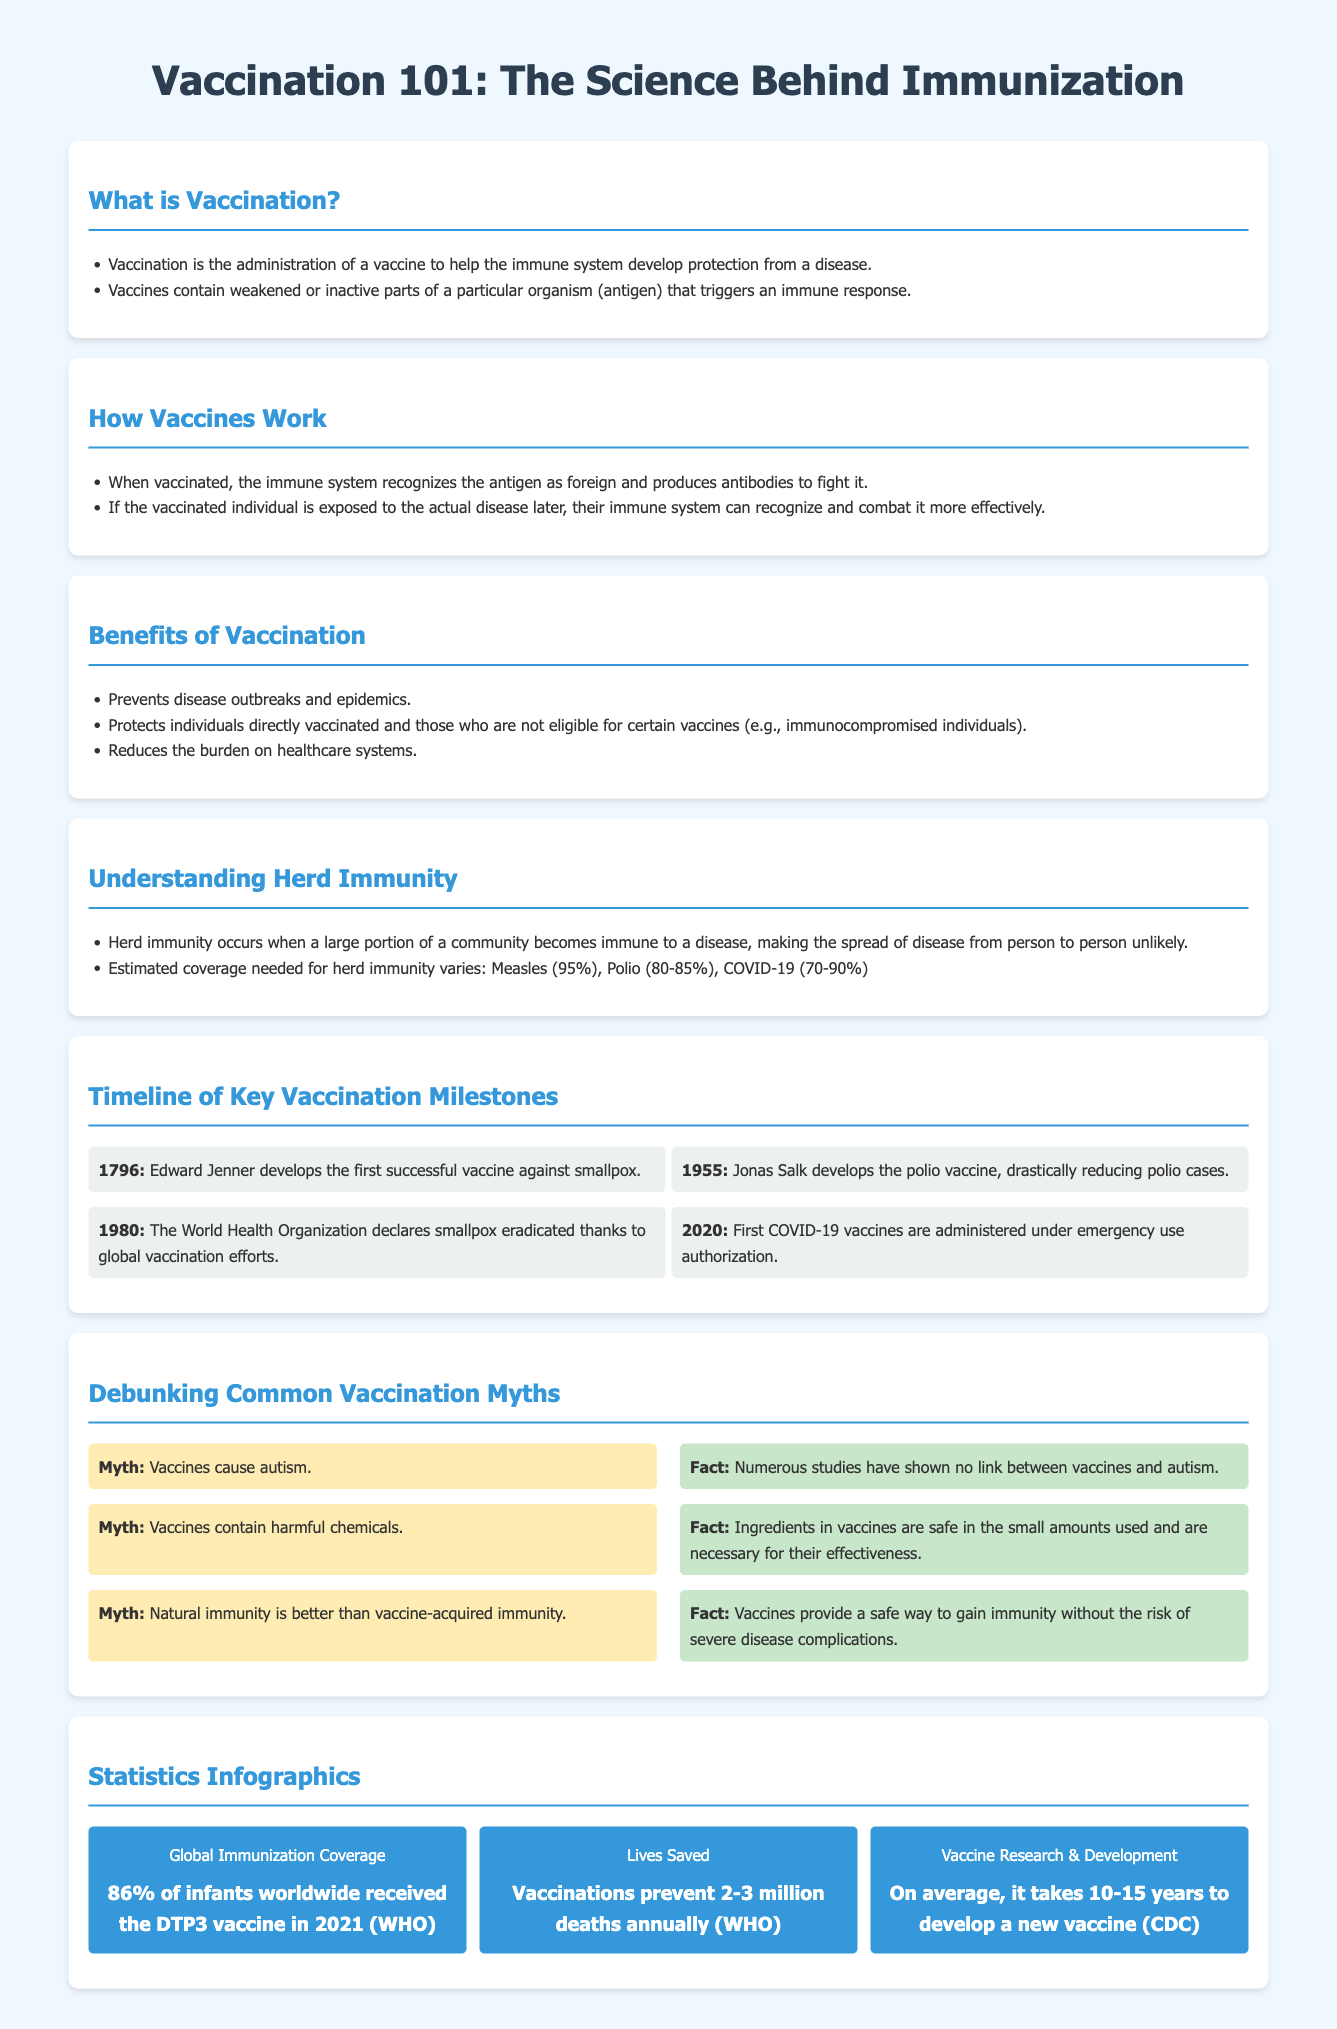What is vaccination? Vaccination is defined in the document as the administration of a vaccine to help the immune system develop protection from a disease.
Answer: Administration of a vaccine What year was the first successful vaccine developed? The timeline mentions that the first successful vaccine against smallpox was developed in 1796 by Edward Jenner.
Answer: 1796 What is the estimated coverage needed for herd immunity against measles? The document states that the estimated coverage needed for herd immunity for measles is 95%.
Answer: 95% How many deaths do vaccinations prevent annually? According to the statistics infographic, vaccinations prevent 2-3 million deaths annually.
Answer: 2-3 million What myth claims that vaccines cause autism? The document lists a common myth that vaccines cause autism.
Answer: Vaccines cause autism What percentage of infants worldwide received the DTP3 vaccine in 2021? The statistic provided indicates that 86% of infants received the DTP3 vaccine in 2021.
Answer: 86% How long does it generally take to develop a new vaccine? The document mentions that, on average, it takes 10-15 years to develop a new vaccine.
Answer: 10-15 years What is one benefit of vaccination mentioned in the document? The document lists that vaccination prevents disease outbreaks as one of its benefits.
Answer: Prevents disease outbreaks 